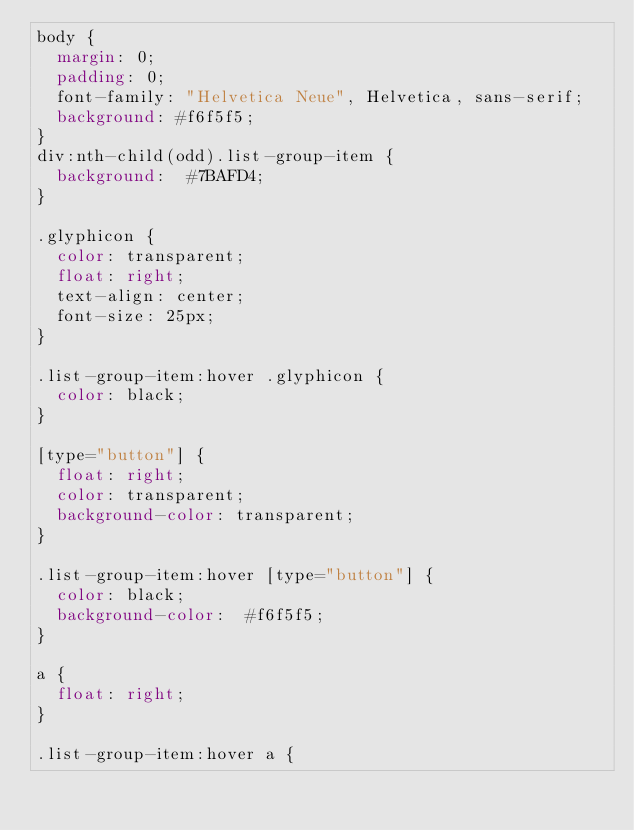<code> <loc_0><loc_0><loc_500><loc_500><_CSS_>body {
  margin: 0;
  padding: 0;
  font-family: "Helvetica Neue", Helvetica, sans-serif;
  background: #f6f5f5;
}
div:nth-child(odd).list-group-item {
	background:  #7BAFD4;
}

.glyphicon {
	color: transparent;
	float: right;
	text-align: center;
	font-size: 25px;
}

.list-group-item:hover .glyphicon {
	color: black;
}

[type="button"] {
	float: right;
	color: transparent;
	background-color: transparent;
}

.list-group-item:hover [type="button"] {
	color: black;
	background-color:  #f6f5f5;
}

a {
	float: right;
}

.list-group-item:hover a {</code> 